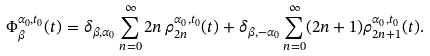Convert formula to latex. <formula><loc_0><loc_0><loc_500><loc_500>\Phi _ { \beta } ^ { \alpha _ { 0 } , t _ { 0 } } ( t ) = \delta _ { \beta , \alpha _ { 0 } } \sum _ { n = 0 } ^ { \infty } 2 n \, \rho _ { 2 n } ^ { \alpha _ { 0 } , t _ { 0 } } ( t ) + \delta _ { \beta , - \alpha _ { 0 } } \sum _ { n = 0 } ^ { \infty } ( 2 n + 1 ) \rho _ { 2 n + 1 } ^ { \alpha _ { 0 } , t _ { 0 } } ( t ) .</formula> 